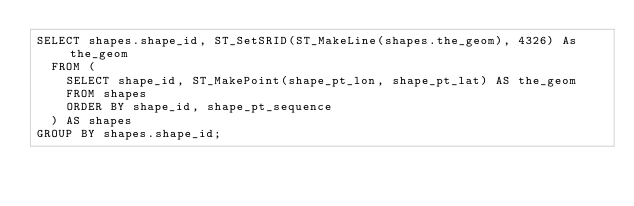Convert code to text. <code><loc_0><loc_0><loc_500><loc_500><_SQL_>SELECT shapes.shape_id, ST_SetSRID(ST_MakeLine(shapes.the_geom), 4326) As the_geom
  FROM (
    SELECT shape_id, ST_MakePoint(shape_pt_lon, shape_pt_lat) AS the_geom
    FROM shapes 
    ORDER BY shape_id, shape_pt_sequence
  ) AS shapes
GROUP BY shapes.shape_id;</code> 